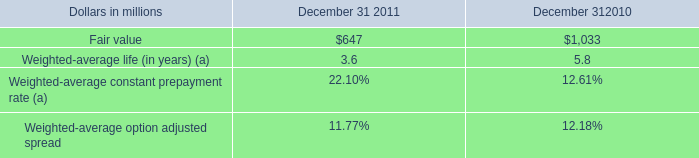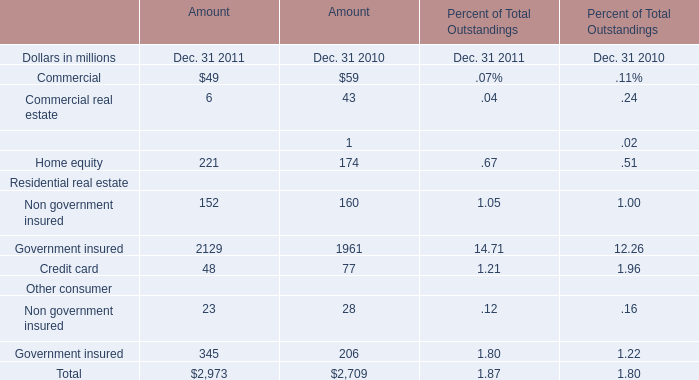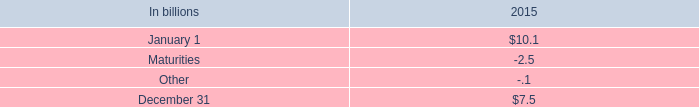What is the difference between the greatest Commercial in 2011 and 2010 ? (in million) 
Computations: (59 - 49)
Answer: 10.0. 